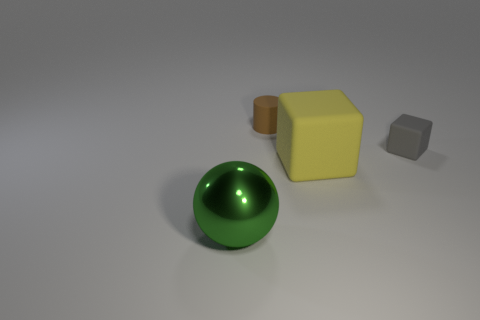What size is the other matte thing that is the same shape as the big yellow thing?
Provide a succinct answer. Small. There is a yellow matte object; does it have the same size as the object to the left of the brown cylinder?
Your answer should be very brief. Yes. Is there anything else that has the same shape as the yellow matte thing?
Make the answer very short. Yes. The brown cylinder has what size?
Provide a succinct answer. Small. Is the number of blocks on the right side of the large cube less than the number of matte cubes?
Make the answer very short. Yes. Is the size of the brown cylinder the same as the yellow cube?
Offer a very short reply. No. Is there anything else that is the same size as the yellow object?
Provide a short and direct response. Yes. There is another large thing that is made of the same material as the gray object; what color is it?
Make the answer very short. Yellow. Is the number of small brown cylinders that are in front of the large green ball less than the number of cylinders behind the large cube?
Provide a succinct answer. Yes. What number of big metallic spheres have the same color as the large rubber block?
Keep it short and to the point. 0. 